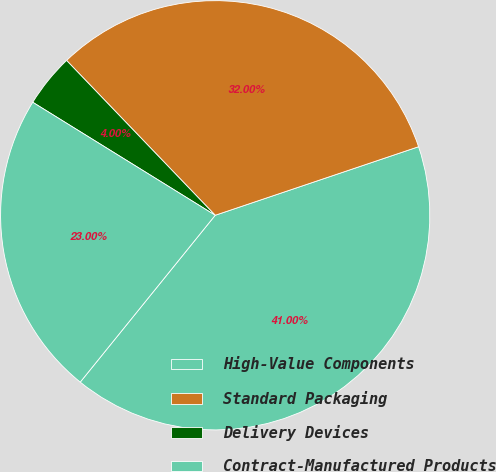Convert chart to OTSL. <chart><loc_0><loc_0><loc_500><loc_500><pie_chart><fcel>High-Value Components<fcel>Standard Packaging<fcel>Delivery Devices<fcel>Contract-Manufactured Products<nl><fcel>41.0%<fcel>32.0%<fcel>4.0%<fcel>23.0%<nl></chart> 